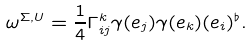<formula> <loc_0><loc_0><loc_500><loc_500>\omega ^ { \Sigma , U } = \frac { 1 } { 4 } \Gamma ^ { k } _ { i j } \gamma ( e _ { j } ) \gamma ( e _ { k } ) ( e _ { i } ) ^ { \flat } .</formula> 